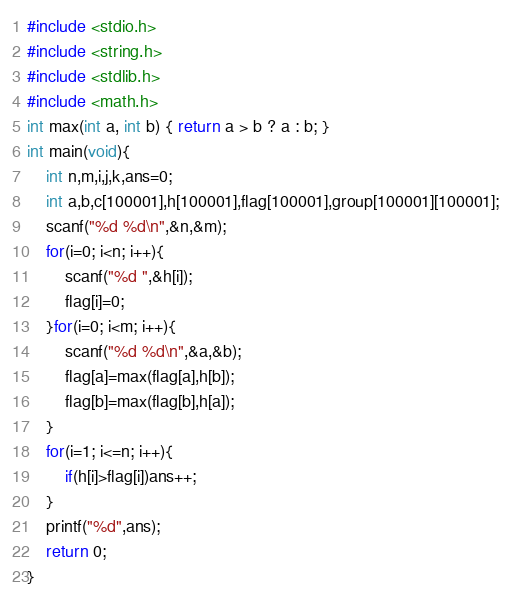<code> <loc_0><loc_0><loc_500><loc_500><_C_>#include <stdio.h>
#include <string.h>
#include <stdlib.h>
#include <math.h>
int max(int a, int b) { return a > b ? a : b; }
int main(void){
    int n,m,i,j,k,ans=0;
    int a,b,c[100001],h[100001],flag[100001],group[100001][100001];
    scanf("%d %d\n",&n,&m);
    for(i=0; i<n; i++){
        scanf("%d ",&h[i]);
        flag[i]=0;
    }for(i=0; i<m; i++){
        scanf("%d %d\n",&a,&b);
        flag[a]=max(flag[a],h[b]);
        flag[b]=max(flag[b],h[a]);
    }
    for(i=1; i<=n; i++){
        if(h[i]>flag[i])ans++;
    }
    printf("%d",ans);
    return 0;
}</code> 